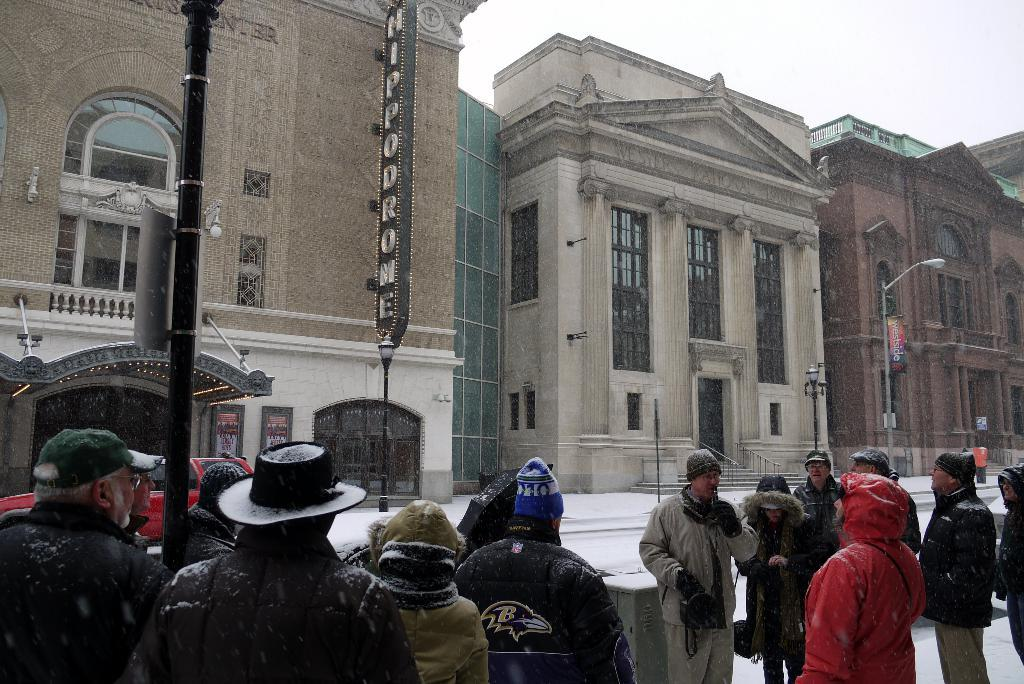How many people can be seen in the image? There are many people in the image. What can be seen in the background of the image? There are buildings, poles, banners, lights, and a car on the road in the background of the image. What is visible at the top of the image? The sky is visible at the top of the image. Can you see a giraffe playing basketball with the powder in the image? No, there is no giraffe, basketball, or powder present in the image. 